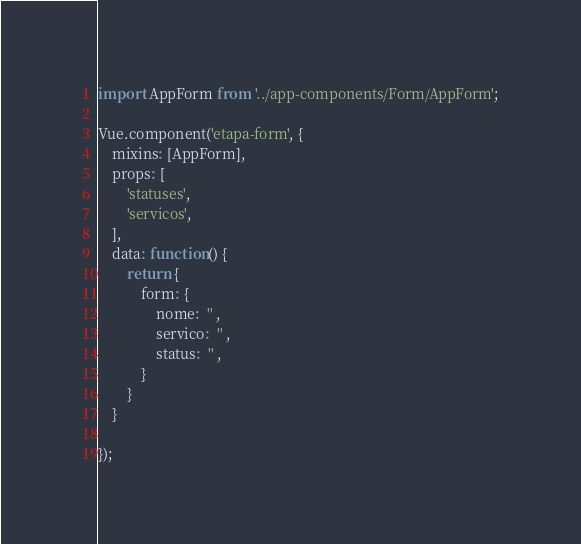Convert code to text. <code><loc_0><loc_0><loc_500><loc_500><_JavaScript_>import AppForm from '../app-components/Form/AppForm';

Vue.component('etapa-form', {
    mixins: [AppForm],
    props: [
        'statuses',
        'servicos',
    ],
    data: function() {
        return {
            form: {
                nome:  '' ,
                servico:  '' ,
                status:  '' ,
            }
        }
    }

});
</code> 